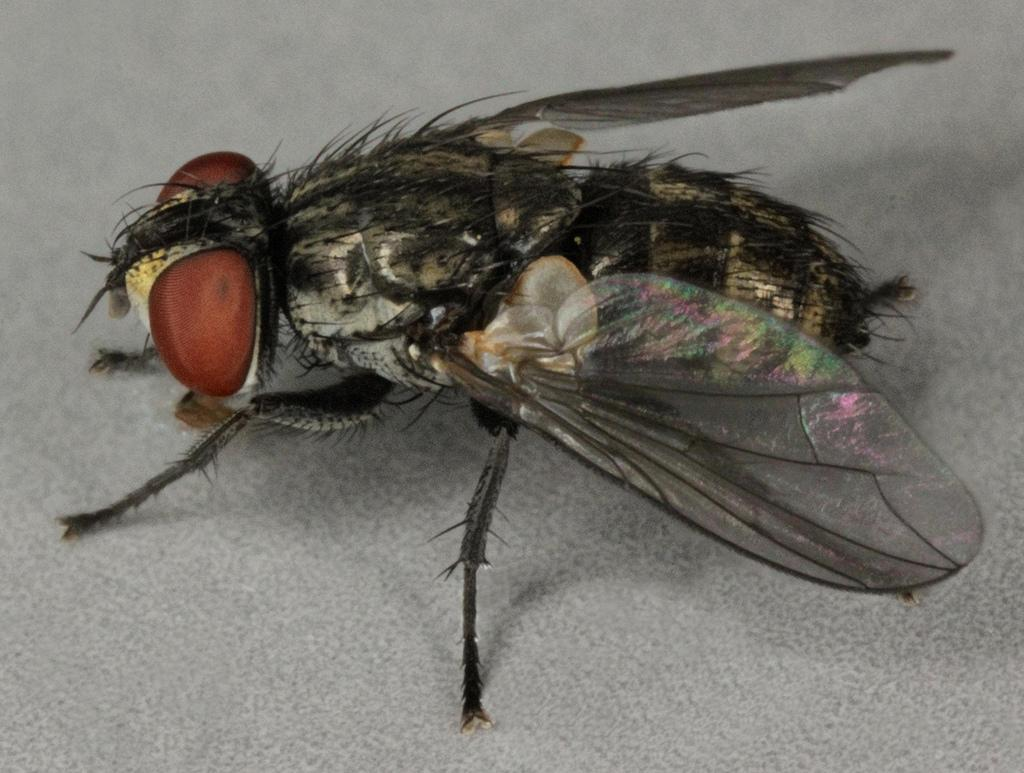What type of insect is present in the image? There is a house fly in the image. Where is the house fly located in the image? The house fly is on a path. What color is the silverware used by the fairies in the image? There are no fairies or silverware present in the image; it only features a house fly on a path. 